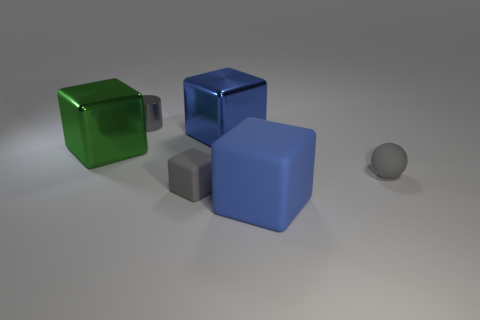There is a matte sphere that is the same color as the metallic cylinder; what size is it?
Your response must be concise. Small. How many blocks are either large blue shiny things or big metal objects?
Offer a very short reply. 2. What shape is the gray object in front of the tiny gray rubber ball?
Ensure brevity in your answer.  Cube. What color is the big shiny object that is on the right side of the large metal block that is left of the tiny thing in front of the small ball?
Keep it short and to the point. Blue. Does the gray cylinder have the same material as the tiny gray sphere?
Ensure brevity in your answer.  No. What number of brown things are small blocks or shiny cubes?
Your answer should be very brief. 0. What number of small gray cylinders are in front of the blue matte cube?
Provide a short and direct response. 0. Is the number of big gray matte blocks greater than the number of gray matte cubes?
Your answer should be compact. No. What shape is the small gray thing that is right of the gray rubber thing that is on the left side of the gray rubber ball?
Your answer should be compact. Sphere. Is the color of the metallic cylinder the same as the tiny rubber sphere?
Your answer should be compact. Yes. 